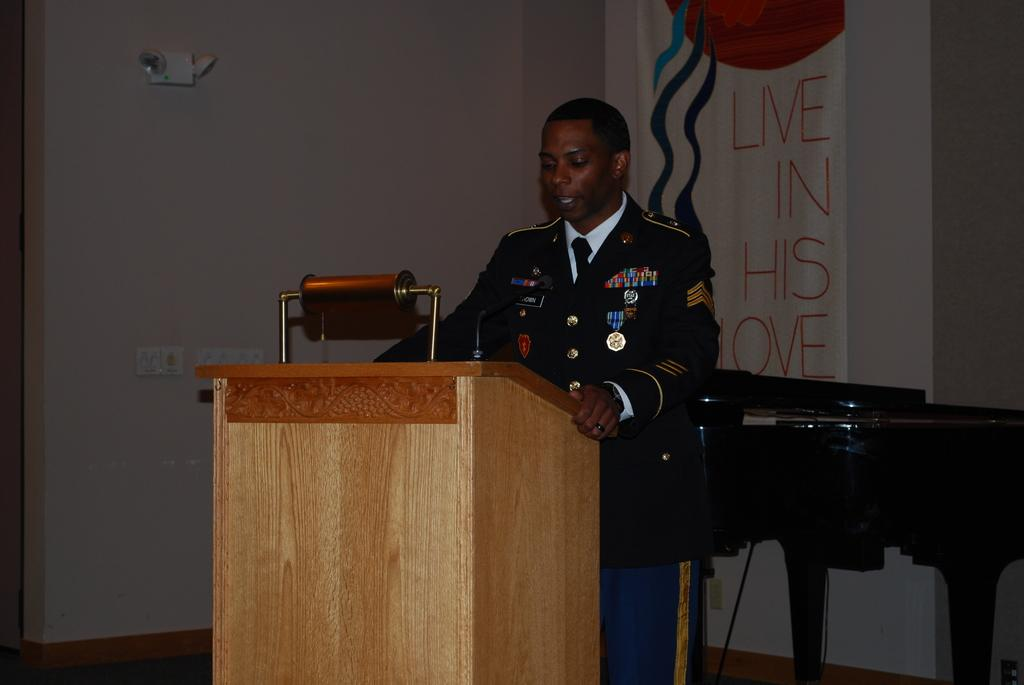Who is the main subject in the image? There is a man in the image. What is the man doing in the image? The man is standing at a podium and speaking. What can be seen in the background of the image? There is a table, a banner, and a wall in the background of the image. What type of food is being served to the pigs in the image? There are no pigs or food present in the image. What type of amusement can be seen in the background of the image? There is no amusement present in the image; it features a man standing at a podium and speaking, with a table, banner, and wall in the background. 